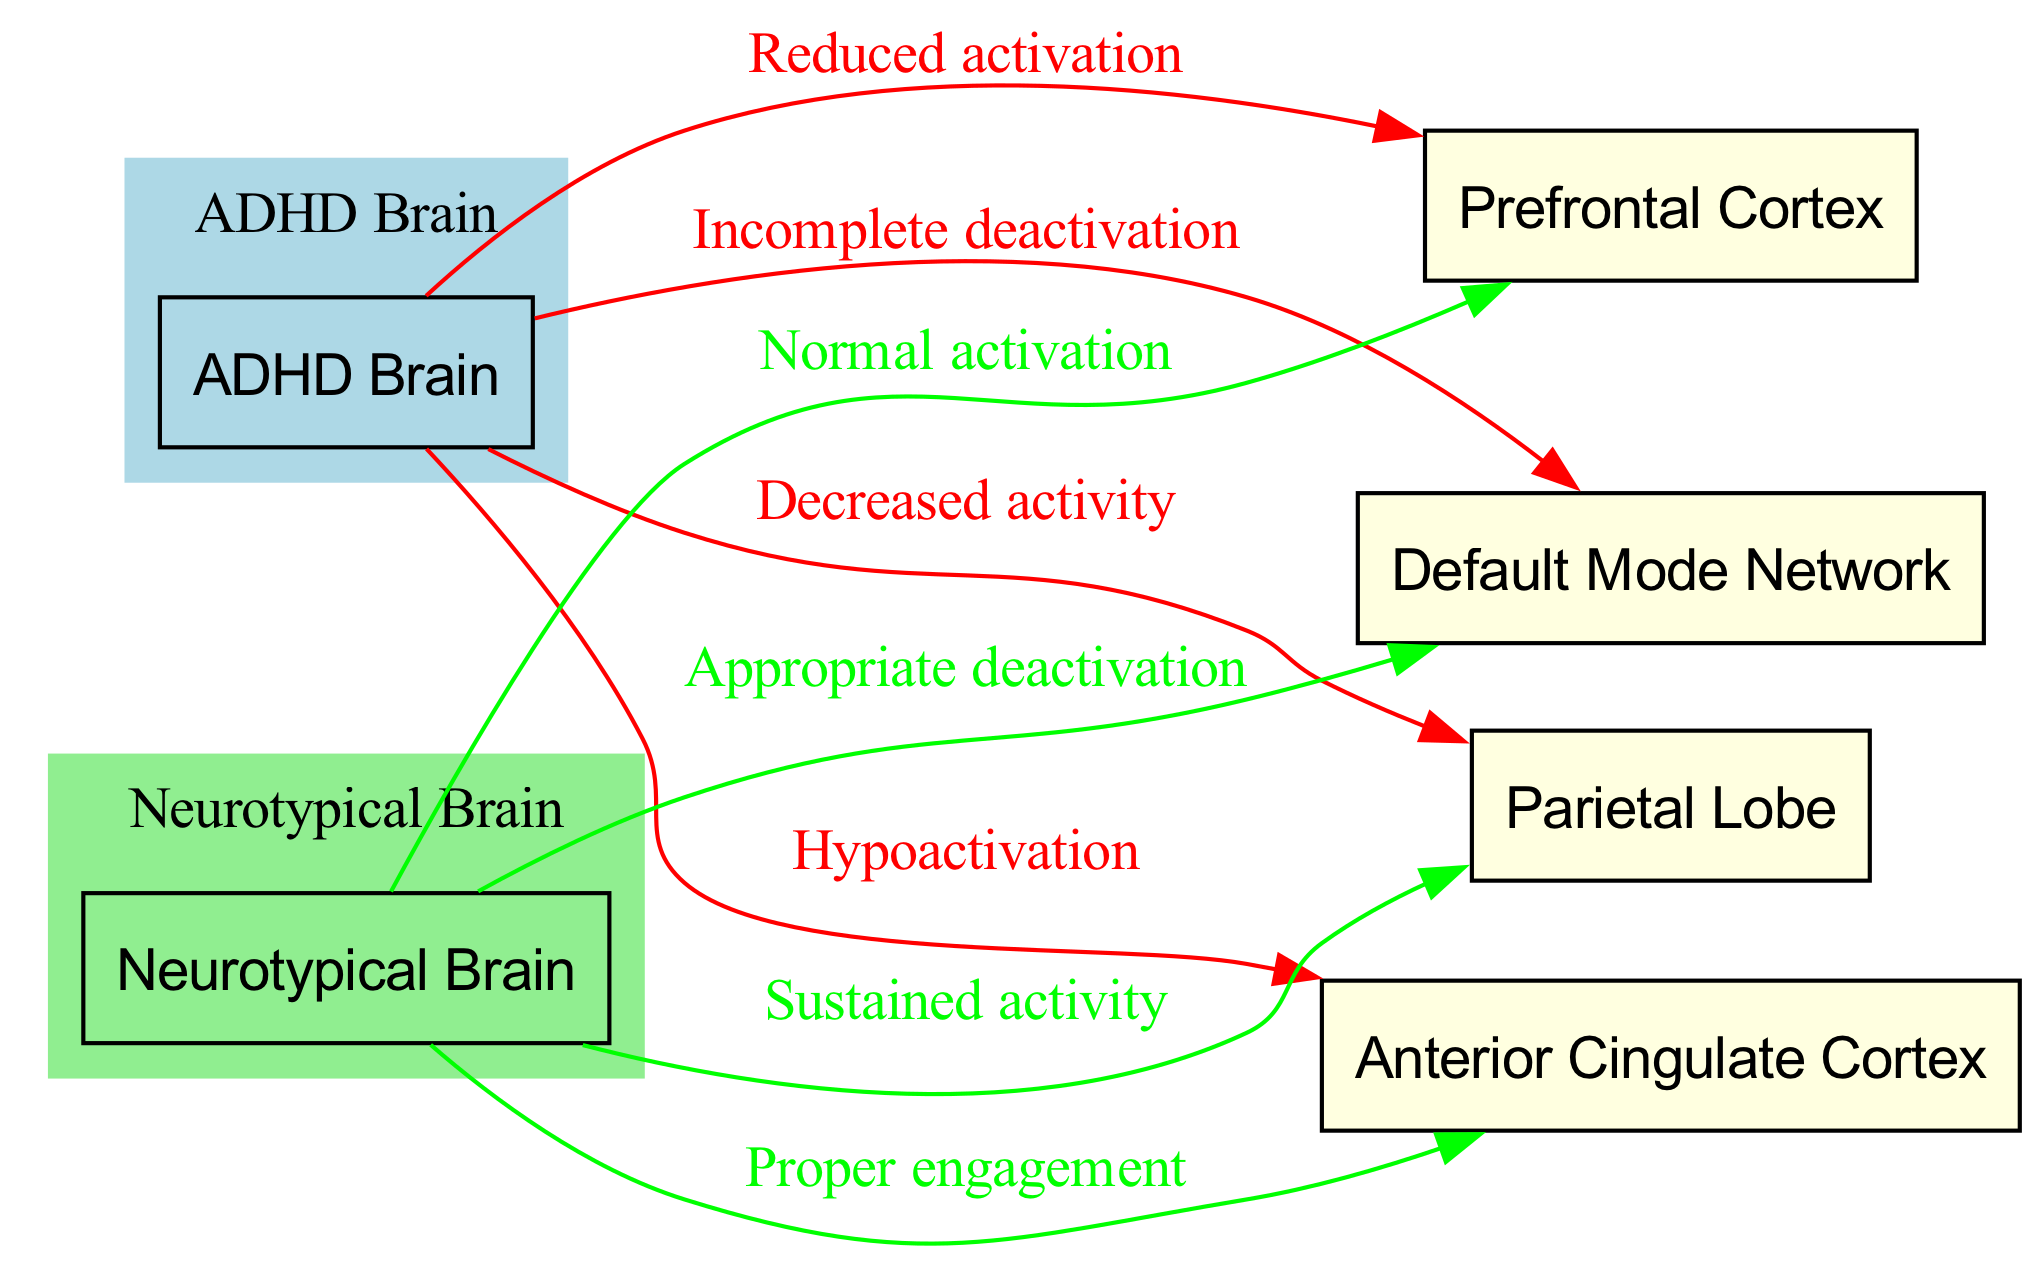What regions show reduced activation in the ADHD brain? The diagram indicates a direct edge from the ADHD Brain node to the Prefrontal Cortex with the label "Reduced activation." Thus, the Prefrontal Cortex is the region with reduced activation.
Answer: Prefrontal Cortex Which brain region has proper engagement in neurotypical individuals? The diagram shows an edge from the Neurotypical Brain node to the Anterior Cingulate Cortex with the label "Proper engagement." Therefore, the Anterior Cingulate Cortex is the brain region with proper engagement in neurotypical individuals.
Answer: Anterior Cingulate Cortex How many brain regions are represented in the diagram? The diagram lists four brain regions: Prefrontal Cortex, Anterior Cingulate Cortex, Parietal Lobe, and Default Mode Network. Counting these, there are four brain regions represented in total.
Answer: Four What type of deactivation is shown as incomplete in the ADHD brain? There is an edge from the ADHD Brain node to the Default Mode Network with the label "Incomplete deactivation." Hence, the type of deactivation that is shown as incomplete is related to the Default Mode Network.
Answer: Default Mode Network Which brain region shows decreased activity in ADHD individuals? The Parietal Lobe node has an edge coming from the ADHD Brain node labeled "Decreased activity." Therefore, the region showing decreased activity in ADHD individuals is the Parietal Lobe.
Answer: Parietal Lobe What is the difference in activity patterns in the Prefrontal Cortex between ADHD and neurotypical brains? The diagram indicates that the Prefrontal Cortex has "Reduced activation" for the ADHD brain and "Normal activation" for the Neurotypical brain. This illustrates a clear difference in the activation patterns between the two groups.
Answer: Reduced activation vs. Normal activation Which region exhibits appropriate deactivation only in neurotypical individuals? According to the diagram, the Default Mode Network has an edge from the Neurotypical Brain node with the label "Appropriate deactivation", signifying that only the neurotypical individuals display this behavior in this region.
Answer: Default Mode Network What do the colors of the nodes represent in the diagram? The colors of the nodes represent groups: light blue for the ADHD brain and light green for the neurotypical brain. This color coding helps visually differentiate between the two brain types being analyzed.
Answer: ADHD Brain: light blue, Neurotypical Brain: light green 